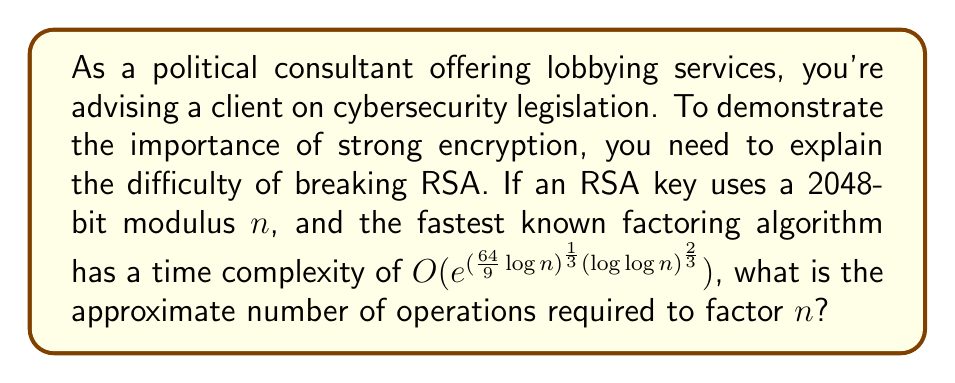Solve this math problem. To solve this problem, we'll follow these steps:

1) The RSA modulus $n$ is 2048 bits long, so $\log n \approx 2048 \log 2$.

2) The time complexity is given by $O(e^{(\frac{64}{9}\log n)^{\frac{1}{3}}(\log \log n)^{\frac{2}{3}}})$.

3) Let's calculate $\log \log n$:
   $\log \log n \approx \log(2048 \log 2) \approx \log 1419 \approx 7.26$

4) Now, let's substitute these values into the expression inside the exponential:

   $$(\frac{64}{9}\log n)^{\frac{1}{3}}(\log \log n)^{\frac{2}{3}}$$
   
   $$\approx (\frac{64}{9} \cdot 2048 \log 2)^{\frac{1}{3}} \cdot (7.26)^{\frac{2}{3}}$$
   
   $$\approx (14563)^{\frac{1}{3}} \cdot (7.26)^{\frac{2}{3}}$$
   
   $$\approx 24.34 \cdot 4.35 \approx 106$$

5) Therefore, the number of operations is approximately:

   $$e^{106} \approx 2^{153}$$

This is an enormously large number, demonstrating the security of RSA with large key sizes.
Answer: $\approx 2^{153}$ operations 